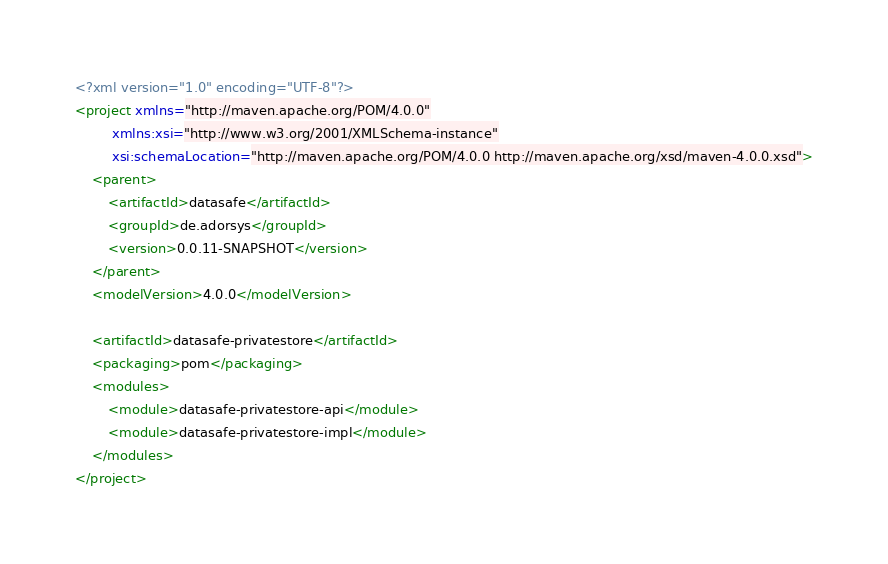Convert code to text. <code><loc_0><loc_0><loc_500><loc_500><_XML_><?xml version="1.0" encoding="UTF-8"?>
<project xmlns="http://maven.apache.org/POM/4.0.0"
         xmlns:xsi="http://www.w3.org/2001/XMLSchema-instance"
         xsi:schemaLocation="http://maven.apache.org/POM/4.0.0 http://maven.apache.org/xsd/maven-4.0.0.xsd">
    <parent>
        <artifactId>datasafe</artifactId>
        <groupId>de.adorsys</groupId>
        <version>0.0.11-SNAPSHOT</version>
    </parent>
    <modelVersion>4.0.0</modelVersion>

    <artifactId>datasafe-privatestore</artifactId>
    <packaging>pom</packaging>
    <modules>
        <module>datasafe-privatestore-api</module>
        <module>datasafe-privatestore-impl</module>
    </modules>
</project>
</code> 